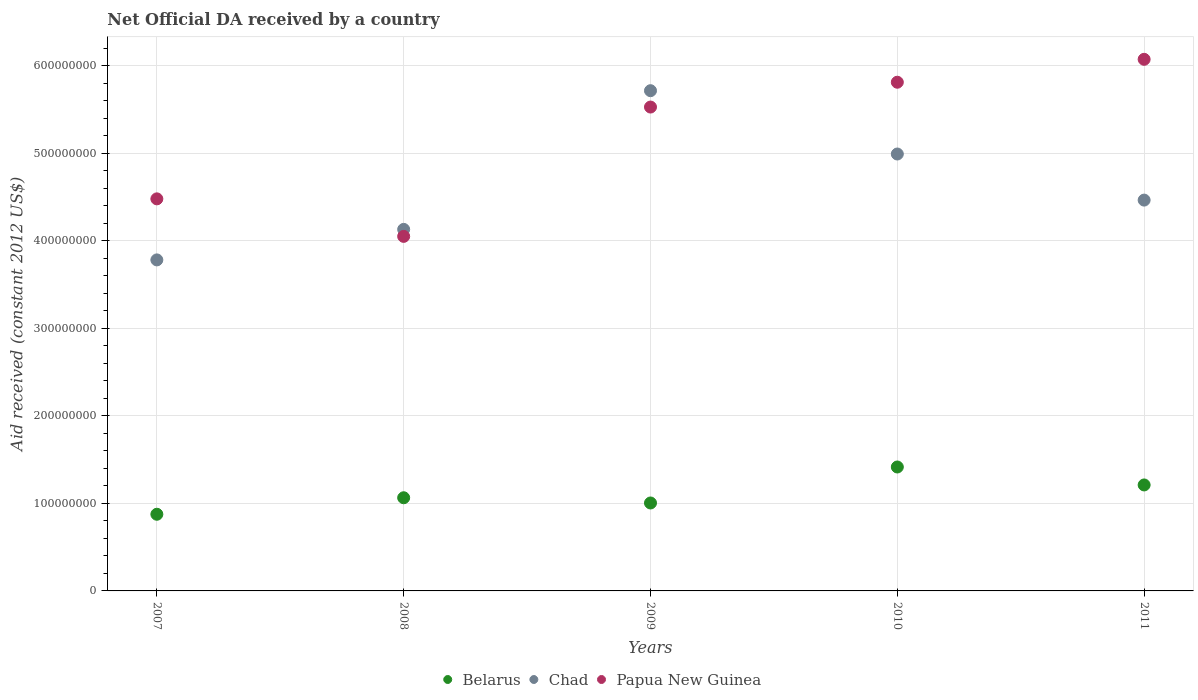How many different coloured dotlines are there?
Keep it short and to the point. 3. Is the number of dotlines equal to the number of legend labels?
Make the answer very short. Yes. What is the net official development assistance aid received in Papua New Guinea in 2009?
Your response must be concise. 5.53e+08. Across all years, what is the maximum net official development assistance aid received in Papua New Guinea?
Make the answer very short. 6.08e+08. Across all years, what is the minimum net official development assistance aid received in Papua New Guinea?
Provide a succinct answer. 4.05e+08. What is the total net official development assistance aid received in Chad in the graph?
Ensure brevity in your answer.  2.31e+09. What is the difference between the net official development assistance aid received in Chad in 2007 and that in 2008?
Ensure brevity in your answer.  -3.49e+07. What is the difference between the net official development assistance aid received in Chad in 2011 and the net official development assistance aid received in Papua New Guinea in 2010?
Your answer should be compact. -1.35e+08. What is the average net official development assistance aid received in Belarus per year?
Offer a terse response. 1.11e+08. In the year 2009, what is the difference between the net official development assistance aid received in Papua New Guinea and net official development assistance aid received in Belarus?
Your answer should be very brief. 4.53e+08. In how many years, is the net official development assistance aid received in Belarus greater than 520000000 US$?
Provide a short and direct response. 0. What is the ratio of the net official development assistance aid received in Chad in 2008 to that in 2011?
Provide a succinct answer. 0.93. Is the net official development assistance aid received in Papua New Guinea in 2007 less than that in 2008?
Offer a very short reply. No. What is the difference between the highest and the second highest net official development assistance aid received in Chad?
Your answer should be compact. 7.24e+07. What is the difference between the highest and the lowest net official development assistance aid received in Papua New Guinea?
Give a very brief answer. 2.02e+08. In how many years, is the net official development assistance aid received in Papua New Guinea greater than the average net official development assistance aid received in Papua New Guinea taken over all years?
Offer a terse response. 3. Is the sum of the net official development assistance aid received in Belarus in 2008 and 2010 greater than the maximum net official development assistance aid received in Papua New Guinea across all years?
Your answer should be compact. No. Is it the case that in every year, the sum of the net official development assistance aid received in Chad and net official development assistance aid received in Papua New Guinea  is greater than the net official development assistance aid received in Belarus?
Make the answer very short. Yes. Does the net official development assistance aid received in Chad monotonically increase over the years?
Ensure brevity in your answer.  No. Is the net official development assistance aid received in Papua New Guinea strictly greater than the net official development assistance aid received in Chad over the years?
Offer a terse response. No. Is the net official development assistance aid received in Chad strictly less than the net official development assistance aid received in Belarus over the years?
Make the answer very short. No. How many dotlines are there?
Offer a terse response. 3. How many years are there in the graph?
Provide a succinct answer. 5. What is the difference between two consecutive major ticks on the Y-axis?
Your answer should be very brief. 1.00e+08. How many legend labels are there?
Make the answer very short. 3. What is the title of the graph?
Provide a short and direct response. Net Official DA received by a country. What is the label or title of the X-axis?
Make the answer very short. Years. What is the label or title of the Y-axis?
Your answer should be compact. Aid received (constant 2012 US$). What is the Aid received (constant 2012 US$) in Belarus in 2007?
Offer a terse response. 8.76e+07. What is the Aid received (constant 2012 US$) in Chad in 2007?
Keep it short and to the point. 3.78e+08. What is the Aid received (constant 2012 US$) of Papua New Guinea in 2007?
Your response must be concise. 4.48e+08. What is the Aid received (constant 2012 US$) in Belarus in 2008?
Offer a terse response. 1.06e+08. What is the Aid received (constant 2012 US$) in Chad in 2008?
Offer a terse response. 4.13e+08. What is the Aid received (constant 2012 US$) in Papua New Guinea in 2008?
Give a very brief answer. 4.05e+08. What is the Aid received (constant 2012 US$) in Belarus in 2009?
Keep it short and to the point. 1.01e+08. What is the Aid received (constant 2012 US$) in Chad in 2009?
Make the answer very short. 5.72e+08. What is the Aid received (constant 2012 US$) in Papua New Guinea in 2009?
Your answer should be compact. 5.53e+08. What is the Aid received (constant 2012 US$) in Belarus in 2010?
Keep it short and to the point. 1.42e+08. What is the Aid received (constant 2012 US$) in Chad in 2010?
Keep it short and to the point. 4.99e+08. What is the Aid received (constant 2012 US$) of Papua New Guinea in 2010?
Ensure brevity in your answer.  5.81e+08. What is the Aid received (constant 2012 US$) in Belarus in 2011?
Your answer should be very brief. 1.21e+08. What is the Aid received (constant 2012 US$) of Chad in 2011?
Your answer should be compact. 4.47e+08. What is the Aid received (constant 2012 US$) of Papua New Guinea in 2011?
Keep it short and to the point. 6.08e+08. Across all years, what is the maximum Aid received (constant 2012 US$) of Belarus?
Your response must be concise. 1.42e+08. Across all years, what is the maximum Aid received (constant 2012 US$) of Chad?
Make the answer very short. 5.72e+08. Across all years, what is the maximum Aid received (constant 2012 US$) of Papua New Guinea?
Make the answer very short. 6.08e+08. Across all years, what is the minimum Aid received (constant 2012 US$) of Belarus?
Offer a very short reply. 8.76e+07. Across all years, what is the minimum Aid received (constant 2012 US$) of Chad?
Offer a terse response. 3.78e+08. Across all years, what is the minimum Aid received (constant 2012 US$) in Papua New Guinea?
Provide a short and direct response. 4.05e+08. What is the total Aid received (constant 2012 US$) in Belarus in the graph?
Your response must be concise. 5.57e+08. What is the total Aid received (constant 2012 US$) in Chad in the graph?
Make the answer very short. 2.31e+09. What is the total Aid received (constant 2012 US$) in Papua New Guinea in the graph?
Offer a terse response. 2.60e+09. What is the difference between the Aid received (constant 2012 US$) in Belarus in 2007 and that in 2008?
Offer a very short reply. -1.89e+07. What is the difference between the Aid received (constant 2012 US$) in Chad in 2007 and that in 2008?
Your answer should be compact. -3.49e+07. What is the difference between the Aid received (constant 2012 US$) in Papua New Guinea in 2007 and that in 2008?
Provide a short and direct response. 4.29e+07. What is the difference between the Aid received (constant 2012 US$) of Belarus in 2007 and that in 2009?
Make the answer very short. -1.29e+07. What is the difference between the Aid received (constant 2012 US$) in Chad in 2007 and that in 2009?
Provide a short and direct response. -1.93e+08. What is the difference between the Aid received (constant 2012 US$) of Papua New Guinea in 2007 and that in 2009?
Ensure brevity in your answer.  -1.05e+08. What is the difference between the Aid received (constant 2012 US$) in Belarus in 2007 and that in 2010?
Ensure brevity in your answer.  -5.40e+07. What is the difference between the Aid received (constant 2012 US$) of Chad in 2007 and that in 2010?
Your answer should be very brief. -1.21e+08. What is the difference between the Aid received (constant 2012 US$) of Papua New Guinea in 2007 and that in 2010?
Offer a terse response. -1.33e+08. What is the difference between the Aid received (constant 2012 US$) in Belarus in 2007 and that in 2011?
Your answer should be very brief. -3.35e+07. What is the difference between the Aid received (constant 2012 US$) of Chad in 2007 and that in 2011?
Keep it short and to the point. -6.84e+07. What is the difference between the Aid received (constant 2012 US$) of Papua New Guinea in 2007 and that in 2011?
Offer a terse response. -1.59e+08. What is the difference between the Aid received (constant 2012 US$) in Belarus in 2008 and that in 2009?
Your answer should be very brief. 5.97e+06. What is the difference between the Aid received (constant 2012 US$) in Chad in 2008 and that in 2009?
Your answer should be compact. -1.59e+08. What is the difference between the Aid received (constant 2012 US$) in Papua New Guinea in 2008 and that in 2009?
Provide a short and direct response. -1.48e+08. What is the difference between the Aid received (constant 2012 US$) in Belarus in 2008 and that in 2010?
Provide a short and direct response. -3.52e+07. What is the difference between the Aid received (constant 2012 US$) of Chad in 2008 and that in 2010?
Your answer should be very brief. -8.62e+07. What is the difference between the Aid received (constant 2012 US$) in Papua New Guinea in 2008 and that in 2010?
Make the answer very short. -1.76e+08. What is the difference between the Aid received (constant 2012 US$) of Belarus in 2008 and that in 2011?
Offer a terse response. -1.46e+07. What is the difference between the Aid received (constant 2012 US$) of Chad in 2008 and that in 2011?
Make the answer very short. -3.35e+07. What is the difference between the Aid received (constant 2012 US$) in Papua New Guinea in 2008 and that in 2011?
Keep it short and to the point. -2.02e+08. What is the difference between the Aid received (constant 2012 US$) of Belarus in 2009 and that in 2010?
Provide a short and direct response. -4.11e+07. What is the difference between the Aid received (constant 2012 US$) in Chad in 2009 and that in 2010?
Keep it short and to the point. 7.24e+07. What is the difference between the Aid received (constant 2012 US$) of Papua New Guinea in 2009 and that in 2010?
Your response must be concise. -2.84e+07. What is the difference between the Aid received (constant 2012 US$) in Belarus in 2009 and that in 2011?
Make the answer very short. -2.06e+07. What is the difference between the Aid received (constant 2012 US$) of Chad in 2009 and that in 2011?
Your response must be concise. 1.25e+08. What is the difference between the Aid received (constant 2012 US$) of Papua New Guinea in 2009 and that in 2011?
Your answer should be compact. -5.46e+07. What is the difference between the Aid received (constant 2012 US$) of Belarus in 2010 and that in 2011?
Keep it short and to the point. 2.05e+07. What is the difference between the Aid received (constant 2012 US$) in Chad in 2010 and that in 2011?
Ensure brevity in your answer.  5.27e+07. What is the difference between the Aid received (constant 2012 US$) in Papua New Guinea in 2010 and that in 2011?
Offer a very short reply. -2.62e+07. What is the difference between the Aid received (constant 2012 US$) in Belarus in 2007 and the Aid received (constant 2012 US$) in Chad in 2008?
Provide a succinct answer. -3.26e+08. What is the difference between the Aid received (constant 2012 US$) of Belarus in 2007 and the Aid received (constant 2012 US$) of Papua New Guinea in 2008?
Your answer should be very brief. -3.18e+08. What is the difference between the Aid received (constant 2012 US$) in Chad in 2007 and the Aid received (constant 2012 US$) in Papua New Guinea in 2008?
Provide a succinct answer. -2.69e+07. What is the difference between the Aid received (constant 2012 US$) in Belarus in 2007 and the Aid received (constant 2012 US$) in Chad in 2009?
Give a very brief answer. -4.84e+08. What is the difference between the Aid received (constant 2012 US$) in Belarus in 2007 and the Aid received (constant 2012 US$) in Papua New Guinea in 2009?
Provide a succinct answer. -4.65e+08. What is the difference between the Aid received (constant 2012 US$) in Chad in 2007 and the Aid received (constant 2012 US$) in Papua New Guinea in 2009?
Make the answer very short. -1.75e+08. What is the difference between the Aid received (constant 2012 US$) of Belarus in 2007 and the Aid received (constant 2012 US$) of Chad in 2010?
Provide a short and direct response. -4.12e+08. What is the difference between the Aid received (constant 2012 US$) in Belarus in 2007 and the Aid received (constant 2012 US$) in Papua New Guinea in 2010?
Provide a succinct answer. -4.94e+08. What is the difference between the Aid received (constant 2012 US$) in Chad in 2007 and the Aid received (constant 2012 US$) in Papua New Guinea in 2010?
Keep it short and to the point. -2.03e+08. What is the difference between the Aid received (constant 2012 US$) in Belarus in 2007 and the Aid received (constant 2012 US$) in Chad in 2011?
Provide a short and direct response. -3.59e+08. What is the difference between the Aid received (constant 2012 US$) of Belarus in 2007 and the Aid received (constant 2012 US$) of Papua New Guinea in 2011?
Make the answer very short. -5.20e+08. What is the difference between the Aid received (constant 2012 US$) in Chad in 2007 and the Aid received (constant 2012 US$) in Papua New Guinea in 2011?
Ensure brevity in your answer.  -2.29e+08. What is the difference between the Aid received (constant 2012 US$) in Belarus in 2008 and the Aid received (constant 2012 US$) in Chad in 2009?
Your response must be concise. -4.65e+08. What is the difference between the Aid received (constant 2012 US$) in Belarus in 2008 and the Aid received (constant 2012 US$) in Papua New Guinea in 2009?
Make the answer very short. -4.47e+08. What is the difference between the Aid received (constant 2012 US$) of Chad in 2008 and the Aid received (constant 2012 US$) of Papua New Guinea in 2009?
Your response must be concise. -1.40e+08. What is the difference between the Aid received (constant 2012 US$) of Belarus in 2008 and the Aid received (constant 2012 US$) of Chad in 2010?
Keep it short and to the point. -3.93e+08. What is the difference between the Aid received (constant 2012 US$) of Belarus in 2008 and the Aid received (constant 2012 US$) of Papua New Guinea in 2010?
Ensure brevity in your answer.  -4.75e+08. What is the difference between the Aid received (constant 2012 US$) in Chad in 2008 and the Aid received (constant 2012 US$) in Papua New Guinea in 2010?
Your response must be concise. -1.68e+08. What is the difference between the Aid received (constant 2012 US$) in Belarus in 2008 and the Aid received (constant 2012 US$) in Chad in 2011?
Give a very brief answer. -3.40e+08. What is the difference between the Aid received (constant 2012 US$) of Belarus in 2008 and the Aid received (constant 2012 US$) of Papua New Guinea in 2011?
Your response must be concise. -5.01e+08. What is the difference between the Aid received (constant 2012 US$) of Chad in 2008 and the Aid received (constant 2012 US$) of Papua New Guinea in 2011?
Offer a terse response. -1.94e+08. What is the difference between the Aid received (constant 2012 US$) of Belarus in 2009 and the Aid received (constant 2012 US$) of Chad in 2010?
Provide a succinct answer. -3.99e+08. What is the difference between the Aid received (constant 2012 US$) of Belarus in 2009 and the Aid received (constant 2012 US$) of Papua New Guinea in 2010?
Offer a very short reply. -4.81e+08. What is the difference between the Aid received (constant 2012 US$) in Chad in 2009 and the Aid received (constant 2012 US$) in Papua New Guinea in 2010?
Give a very brief answer. -9.68e+06. What is the difference between the Aid received (constant 2012 US$) of Belarus in 2009 and the Aid received (constant 2012 US$) of Chad in 2011?
Keep it short and to the point. -3.46e+08. What is the difference between the Aid received (constant 2012 US$) of Belarus in 2009 and the Aid received (constant 2012 US$) of Papua New Guinea in 2011?
Your answer should be compact. -5.07e+08. What is the difference between the Aid received (constant 2012 US$) of Chad in 2009 and the Aid received (constant 2012 US$) of Papua New Guinea in 2011?
Make the answer very short. -3.59e+07. What is the difference between the Aid received (constant 2012 US$) of Belarus in 2010 and the Aid received (constant 2012 US$) of Chad in 2011?
Make the answer very short. -3.05e+08. What is the difference between the Aid received (constant 2012 US$) of Belarus in 2010 and the Aid received (constant 2012 US$) of Papua New Guinea in 2011?
Offer a very short reply. -4.66e+08. What is the difference between the Aid received (constant 2012 US$) in Chad in 2010 and the Aid received (constant 2012 US$) in Papua New Guinea in 2011?
Provide a succinct answer. -1.08e+08. What is the average Aid received (constant 2012 US$) of Belarus per year?
Your answer should be very brief. 1.11e+08. What is the average Aid received (constant 2012 US$) of Chad per year?
Your answer should be compact. 4.62e+08. What is the average Aid received (constant 2012 US$) in Papua New Guinea per year?
Provide a short and direct response. 5.19e+08. In the year 2007, what is the difference between the Aid received (constant 2012 US$) of Belarus and Aid received (constant 2012 US$) of Chad?
Your response must be concise. -2.91e+08. In the year 2007, what is the difference between the Aid received (constant 2012 US$) in Belarus and Aid received (constant 2012 US$) in Papua New Guinea?
Ensure brevity in your answer.  -3.60e+08. In the year 2007, what is the difference between the Aid received (constant 2012 US$) in Chad and Aid received (constant 2012 US$) in Papua New Guinea?
Your response must be concise. -6.98e+07. In the year 2008, what is the difference between the Aid received (constant 2012 US$) of Belarus and Aid received (constant 2012 US$) of Chad?
Keep it short and to the point. -3.07e+08. In the year 2008, what is the difference between the Aid received (constant 2012 US$) of Belarus and Aid received (constant 2012 US$) of Papua New Guinea?
Provide a short and direct response. -2.99e+08. In the year 2008, what is the difference between the Aid received (constant 2012 US$) in Chad and Aid received (constant 2012 US$) in Papua New Guinea?
Make the answer very short. 7.99e+06. In the year 2009, what is the difference between the Aid received (constant 2012 US$) in Belarus and Aid received (constant 2012 US$) in Chad?
Your answer should be very brief. -4.71e+08. In the year 2009, what is the difference between the Aid received (constant 2012 US$) of Belarus and Aid received (constant 2012 US$) of Papua New Guinea?
Your answer should be compact. -4.53e+08. In the year 2009, what is the difference between the Aid received (constant 2012 US$) in Chad and Aid received (constant 2012 US$) in Papua New Guinea?
Keep it short and to the point. 1.87e+07. In the year 2010, what is the difference between the Aid received (constant 2012 US$) in Belarus and Aid received (constant 2012 US$) in Chad?
Provide a succinct answer. -3.58e+08. In the year 2010, what is the difference between the Aid received (constant 2012 US$) in Belarus and Aid received (constant 2012 US$) in Papua New Guinea?
Keep it short and to the point. -4.40e+08. In the year 2010, what is the difference between the Aid received (constant 2012 US$) in Chad and Aid received (constant 2012 US$) in Papua New Guinea?
Offer a terse response. -8.20e+07. In the year 2011, what is the difference between the Aid received (constant 2012 US$) of Belarus and Aid received (constant 2012 US$) of Chad?
Ensure brevity in your answer.  -3.26e+08. In the year 2011, what is the difference between the Aid received (constant 2012 US$) of Belarus and Aid received (constant 2012 US$) of Papua New Guinea?
Ensure brevity in your answer.  -4.86e+08. In the year 2011, what is the difference between the Aid received (constant 2012 US$) of Chad and Aid received (constant 2012 US$) of Papua New Guinea?
Keep it short and to the point. -1.61e+08. What is the ratio of the Aid received (constant 2012 US$) of Belarus in 2007 to that in 2008?
Provide a succinct answer. 0.82. What is the ratio of the Aid received (constant 2012 US$) in Chad in 2007 to that in 2008?
Ensure brevity in your answer.  0.92. What is the ratio of the Aid received (constant 2012 US$) in Papua New Guinea in 2007 to that in 2008?
Your answer should be very brief. 1.11. What is the ratio of the Aid received (constant 2012 US$) in Belarus in 2007 to that in 2009?
Your answer should be very brief. 0.87. What is the ratio of the Aid received (constant 2012 US$) in Chad in 2007 to that in 2009?
Your answer should be compact. 0.66. What is the ratio of the Aid received (constant 2012 US$) of Papua New Guinea in 2007 to that in 2009?
Offer a terse response. 0.81. What is the ratio of the Aid received (constant 2012 US$) of Belarus in 2007 to that in 2010?
Make the answer very short. 0.62. What is the ratio of the Aid received (constant 2012 US$) in Chad in 2007 to that in 2010?
Keep it short and to the point. 0.76. What is the ratio of the Aid received (constant 2012 US$) of Papua New Guinea in 2007 to that in 2010?
Your response must be concise. 0.77. What is the ratio of the Aid received (constant 2012 US$) in Belarus in 2007 to that in 2011?
Give a very brief answer. 0.72. What is the ratio of the Aid received (constant 2012 US$) of Chad in 2007 to that in 2011?
Ensure brevity in your answer.  0.85. What is the ratio of the Aid received (constant 2012 US$) in Papua New Guinea in 2007 to that in 2011?
Your answer should be very brief. 0.74. What is the ratio of the Aid received (constant 2012 US$) of Belarus in 2008 to that in 2009?
Your response must be concise. 1.06. What is the ratio of the Aid received (constant 2012 US$) in Chad in 2008 to that in 2009?
Offer a terse response. 0.72. What is the ratio of the Aid received (constant 2012 US$) in Papua New Guinea in 2008 to that in 2009?
Provide a succinct answer. 0.73. What is the ratio of the Aid received (constant 2012 US$) of Belarus in 2008 to that in 2010?
Your response must be concise. 0.75. What is the ratio of the Aid received (constant 2012 US$) in Chad in 2008 to that in 2010?
Keep it short and to the point. 0.83. What is the ratio of the Aid received (constant 2012 US$) in Papua New Guinea in 2008 to that in 2010?
Your answer should be very brief. 0.7. What is the ratio of the Aid received (constant 2012 US$) in Belarus in 2008 to that in 2011?
Make the answer very short. 0.88. What is the ratio of the Aid received (constant 2012 US$) of Chad in 2008 to that in 2011?
Your answer should be very brief. 0.93. What is the ratio of the Aid received (constant 2012 US$) of Papua New Guinea in 2008 to that in 2011?
Your answer should be compact. 0.67. What is the ratio of the Aid received (constant 2012 US$) in Belarus in 2009 to that in 2010?
Give a very brief answer. 0.71. What is the ratio of the Aid received (constant 2012 US$) of Chad in 2009 to that in 2010?
Your answer should be compact. 1.14. What is the ratio of the Aid received (constant 2012 US$) of Papua New Guinea in 2009 to that in 2010?
Ensure brevity in your answer.  0.95. What is the ratio of the Aid received (constant 2012 US$) of Belarus in 2009 to that in 2011?
Your response must be concise. 0.83. What is the ratio of the Aid received (constant 2012 US$) of Chad in 2009 to that in 2011?
Keep it short and to the point. 1.28. What is the ratio of the Aid received (constant 2012 US$) in Papua New Guinea in 2009 to that in 2011?
Provide a short and direct response. 0.91. What is the ratio of the Aid received (constant 2012 US$) in Belarus in 2010 to that in 2011?
Offer a terse response. 1.17. What is the ratio of the Aid received (constant 2012 US$) in Chad in 2010 to that in 2011?
Your response must be concise. 1.12. What is the ratio of the Aid received (constant 2012 US$) in Papua New Guinea in 2010 to that in 2011?
Keep it short and to the point. 0.96. What is the difference between the highest and the second highest Aid received (constant 2012 US$) of Belarus?
Offer a terse response. 2.05e+07. What is the difference between the highest and the second highest Aid received (constant 2012 US$) in Chad?
Provide a short and direct response. 7.24e+07. What is the difference between the highest and the second highest Aid received (constant 2012 US$) in Papua New Guinea?
Provide a short and direct response. 2.62e+07. What is the difference between the highest and the lowest Aid received (constant 2012 US$) of Belarus?
Keep it short and to the point. 5.40e+07. What is the difference between the highest and the lowest Aid received (constant 2012 US$) of Chad?
Ensure brevity in your answer.  1.93e+08. What is the difference between the highest and the lowest Aid received (constant 2012 US$) of Papua New Guinea?
Offer a terse response. 2.02e+08. 